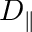<formula> <loc_0><loc_0><loc_500><loc_500>D _ { \| }</formula> 